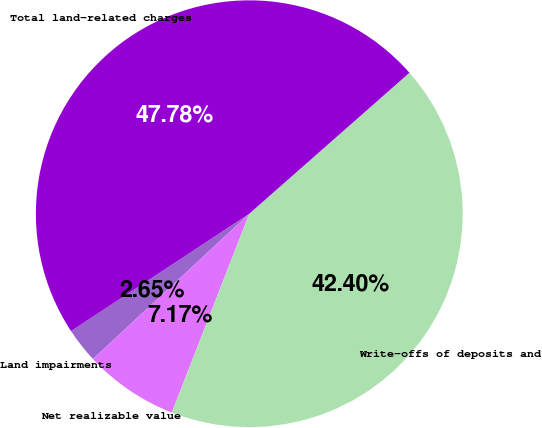Convert chart. <chart><loc_0><loc_0><loc_500><loc_500><pie_chart><fcel>Land impairments<fcel>Net realizable value<fcel>Write-offs of deposits and<fcel>Total land-related charges<nl><fcel>2.65%<fcel>7.17%<fcel>42.4%<fcel>47.78%<nl></chart> 